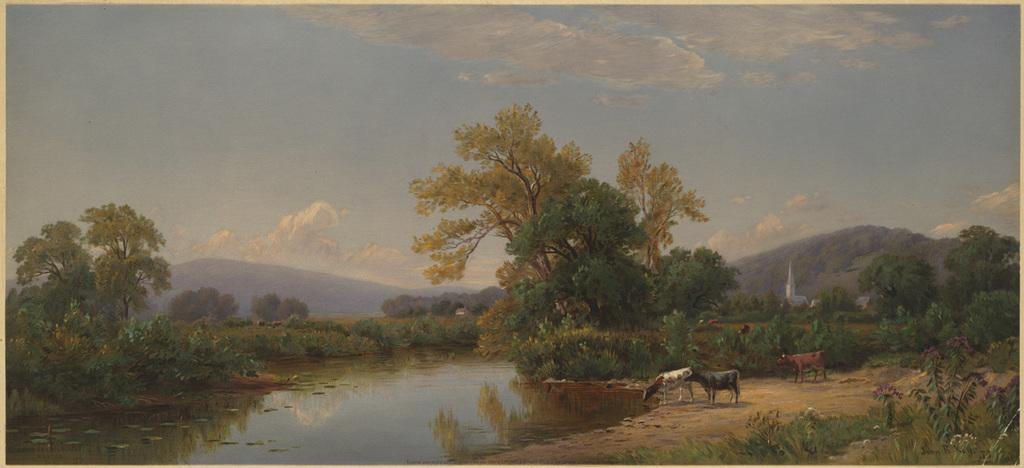What type of artwork is depicted in the image? The image is a painting. What natural elements can be seen in the painting? There are trees and a canal on the left side of the painting. What type of animals are present in the painting? There are animals in the center of the painting. What landscape features are visible in the background of the painting? There are hills in the background of the painting, and the sky is also visible. Can you describe the hen and its fight with the horse in the painting? There is no hen or horse present in the painting, nor is there any fight depicted. 